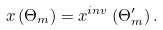<formula> <loc_0><loc_0><loc_500><loc_500>x \left ( \Theta _ { m } \right ) = x ^ { i n v } \left ( \Theta _ { m } ^ { \prime } \right ) .</formula> 